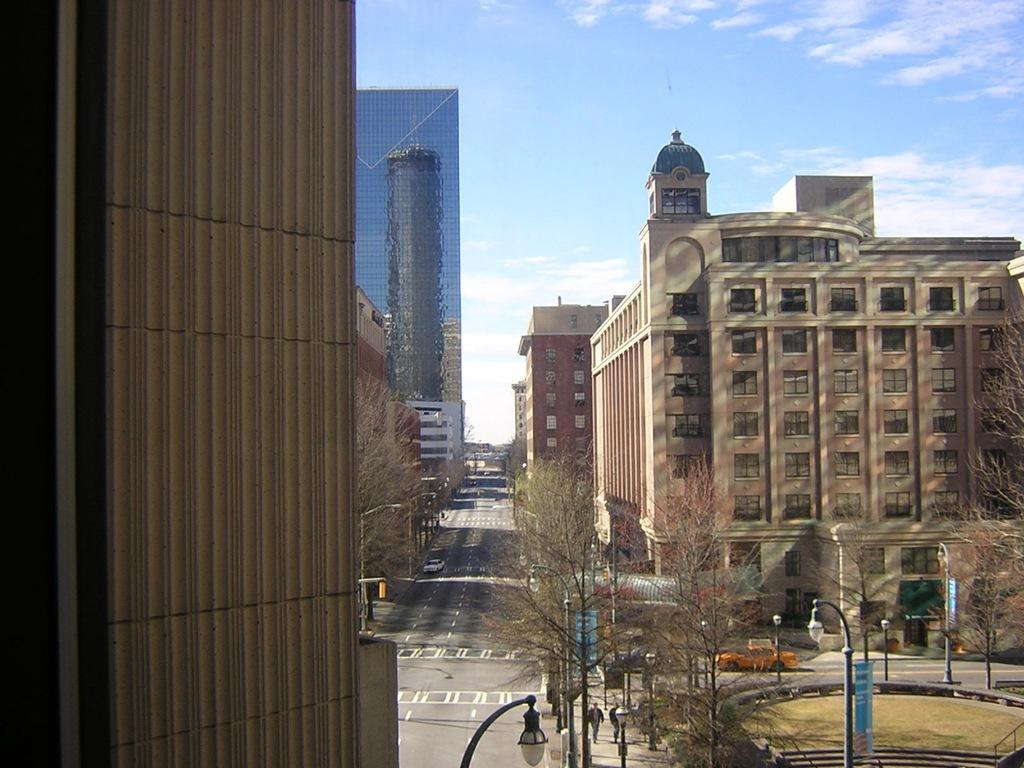What type of structures can be seen in the image? There are buildings in the image. What architectural elements are present in the image? There are walls and windows visible in the image. What type of vegetation is present in the image? There are trees in the image. What is at the bottom of the image? There are roads at the bottom of the image. What is moving on the roads? There are vehicles on the roads. Are there any people in the image? Yes, there are people in the image. What other objects can be seen in the image? There are poles, street lights, and banners in the image. What can be seen in the background of the image? The sky is visible in the background of the image. What type of jeans can be seen hanging from the street lights in the image? There are no jeans present in the image; only poles, street lights, and banners are visible. Can you tell me how many jellyfish are swimming in the sky in the image? There are no jellyfish present in the image; only buildings, walls, windows, trees, roads, vehicles, people, poles, street lights, banners, and the sky are visible. 